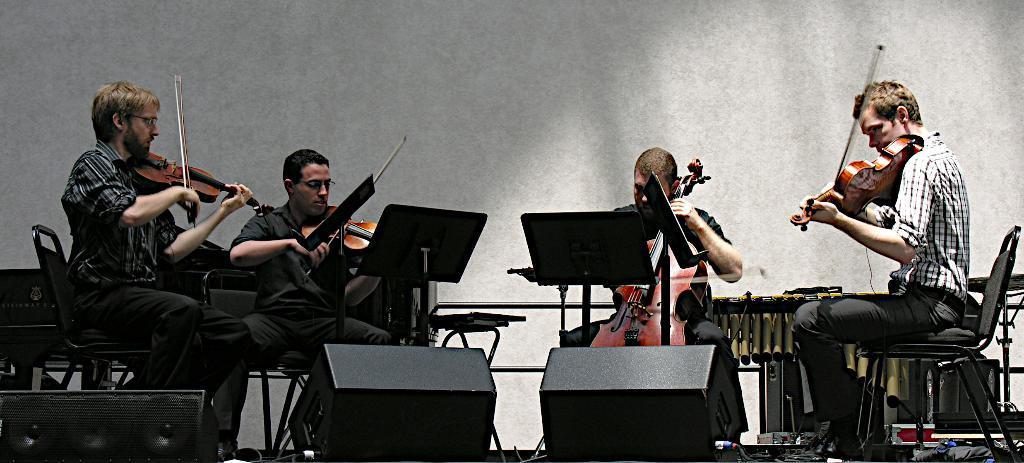Please provide a concise description of this image. In this picture we can see four people sitting on the chairs and holding some musical instruments and among them there are wearing black color shirts and black color pant and the other guy is wearing white and black checks shirt and there are some speakers in the room and the background is ash in color. 